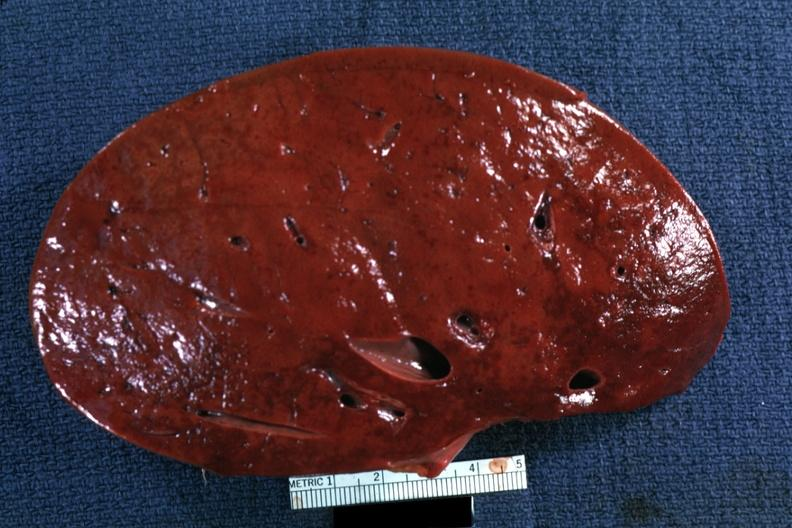what is present?
Answer the question using a single word or phrase. Hodgkins disease 